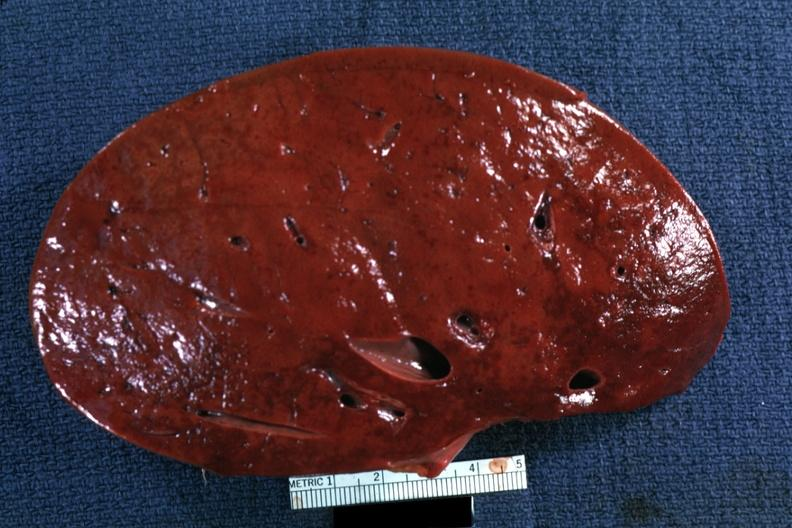what is present?
Answer the question using a single word or phrase. Hodgkins disease 